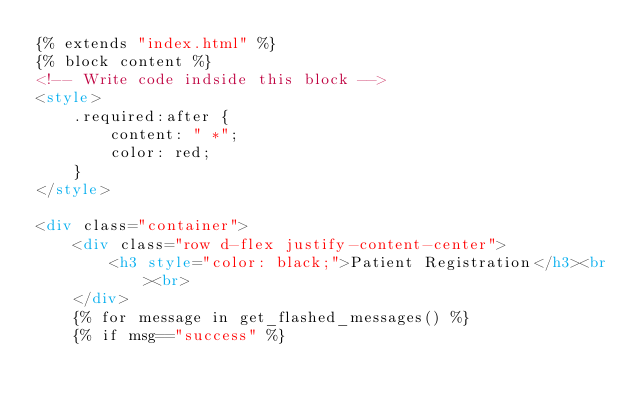<code> <loc_0><loc_0><loc_500><loc_500><_HTML_>{% extends "index.html" %}
{% block content %}
<!-- Write code indside this block -->
<style>
    .required:after {
        content: " *";
        color: red;
    }
</style>

<div class="container">
    <div class="row d-flex justify-content-center">
        <h3 style="color: black;">Patient Registration</h3><br><br>
    </div>
    {% for message in get_flashed_messages() %}
    {% if msg=="success" %}</code> 